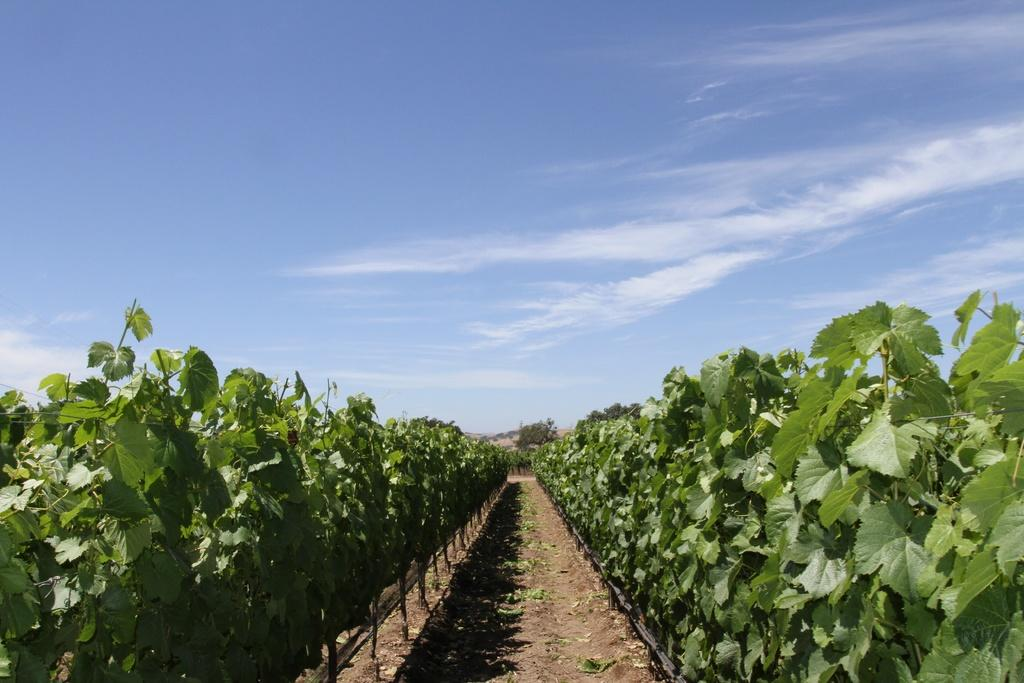What is present on either side of the image? There are plants on either side of the image. What is visible at the top of the image? The sky is visible at the top of the image. How does the sky appear in the image? The sky appears to be cloudy in the image. Can you see a robin pulling a stocking in the image? No, there is no robin or stocking present in the image. 